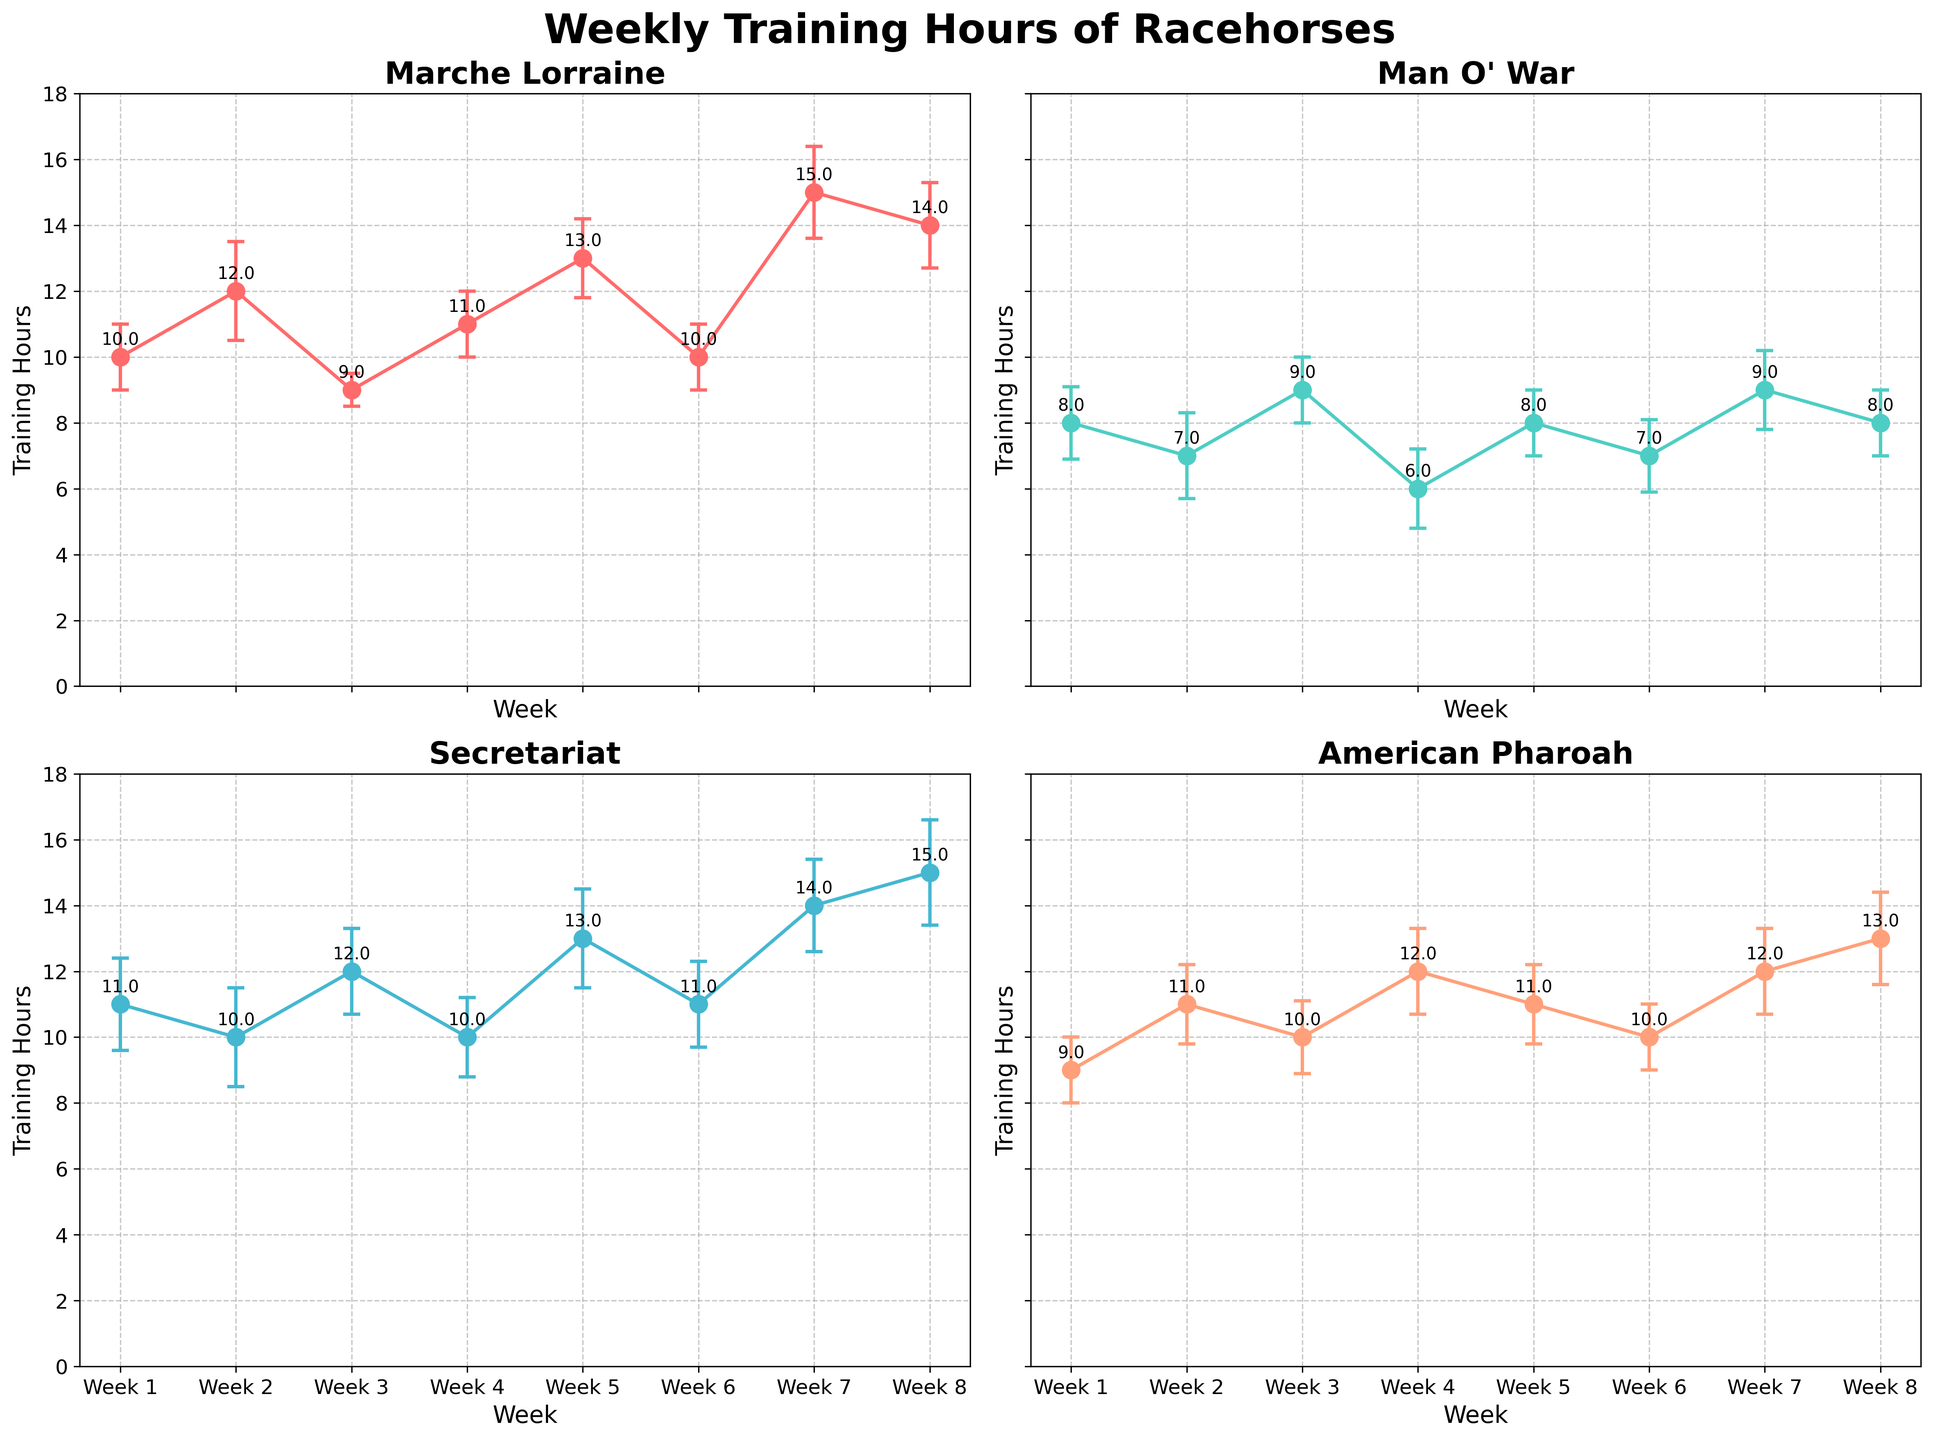What's the title of the chart? The title is usually located at the top of the chart. In this case, it reads "Weekly Training Hours of Racehorses".
Answer: Weekly Training Hours of Racehorses How many weeks of data are plotted for each horse? Each subplot shows data points labeled Week 1 to Week 8, indicating that data from 8 weeks is plotted.
Answer: 8 weeks Which horse has the highest training hours in Week 7? In Week 7, the subplot for each horse shows data points with training hours. Marche Lorraine has 15 hours, Secretariat has 14 hours, Man O' War has 9 hours, and American Pharoah has 12 hours. Therefore, Marche Lorraine has the highest training hours in Week 7.
Answer: Marche Lorraine What's the standard deviation of the training hours for Man O' War in Week 3? For Man O' War in Week 3, the error bar indicates the standard deviation, which is shown as 1.0.
Answer: 1.0 Compare the training hours of Marche Lorraine and Secretariat in Week 5. For Week 5, Marche Lorraine has 13 hours while Secretariat has 13 hours as well. Thus, both have equal training hours.
Answer: Both have 13 hours What's the average training hours for American Pharoah across all weeks? Add American Pharoah's training hours across all weeks (9 + 11 + 10 + 12 + 11 + 10 + 12 + 13) which sums to 88. Then divide by 8 weeks (88/8 = 11).
Answer: 11 hours Which horse has the lowest average training hours across all weeks? Calculate the average training hours for each horse:
- Marche Lorraine: (10 + 12 + 9 + 11 + 13 + 10 + 15 + 14) / 8 = 11.75
- Man O' War: (8 + 7 + 9 + 6 + 8 + 7 + 9 + 8) / 8 = 7.75
- Secretariat: (11 + 10 + 12 + 10 + 13 + 11 + 14 + 15) / 8 = 12
- American Pharoah: (9 + 11 + 10 + 12 + 11 + 10 + 12 + 13) / 8 = 11
Man O' War has the lowest average training hours.
Answer: Man O' War What trend do you observe in the training hours of Secretariat over the 8 weeks? Observing the plot for Secretariat, the training hours start at 11, dip to 10, rise to 12, dip again to 10, then show a consistent increasing trend to 15 by Week 8. The overall trend is an increase over the weeks.
Answer: Increasing trend In which week does Marche Lorraine have the lowest training hours, and what is the value? For Marche Lorraine, the lowest training hours occur in Week 3 with 9 hours.
Answer: Week 3, 9 hours Which horse shows the most variability in training hours based on the standard deviations over the 8 weeks? The variability is indicated by the size of the error bars (standard deviations). Adding the standard deviations:
- Marche Lorraine: 1 + 1.5 + 0.5 + 1 + 1.2 + 1 + 1.4 + 1.3 = 9.9
- Man O' War: 1.1 + 1.3 + 1 + 1.2 + 1 + 1.1 + 1.2 + 1 = 8.9
- Secretariat: 1.4 + 1.5 + 1.3 + 1.2 + 1.5 + 1.3 + 1.4 + 1.6 = 11.2
- American Pharoah: 1 + 1.2 + 1.1 + 1.3 + 1.2 + 1 + 1.3 + 1.4 = 9.5
Secretariat shows the most variability.
Answer: Secretariat 